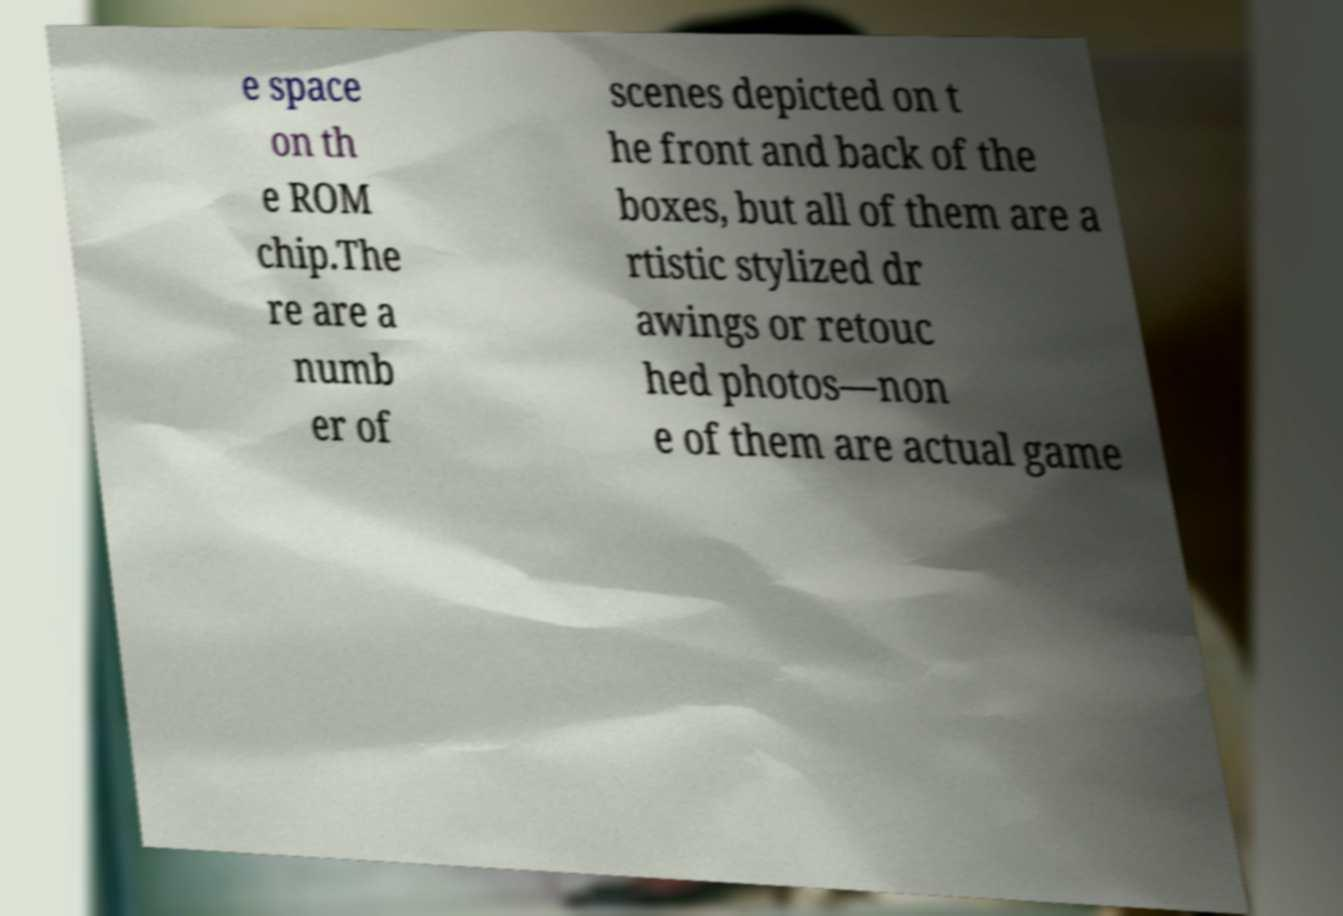Please identify and transcribe the text found in this image. e space on th e ROM chip.The re are a numb er of scenes depicted on t he front and back of the boxes, but all of them are a rtistic stylized dr awings or retouc hed photos—non e of them are actual game 